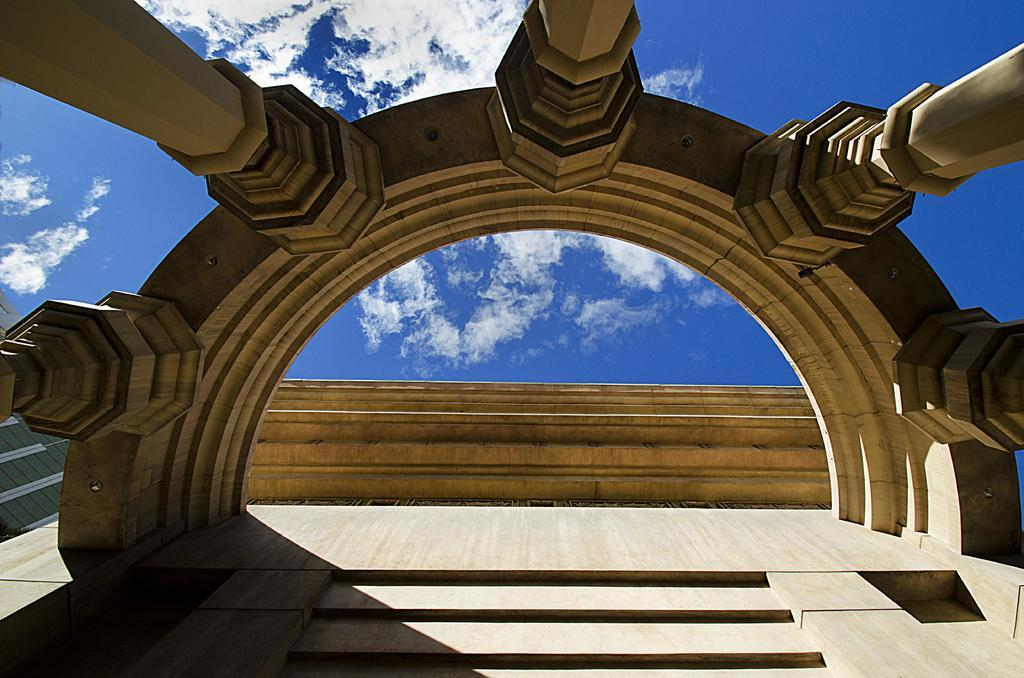What can be seen on the wall in the image? There is a wall with pillars and a design in the image. What is visible in the background of the image? The sky is visible in the background of the image. How would you describe the sky in the image? The sky appears to be cloudy in the image. Where is the key located in the image? There is no key present in the image. What type of waste can be seen in the image? There is no waste present in the image. 